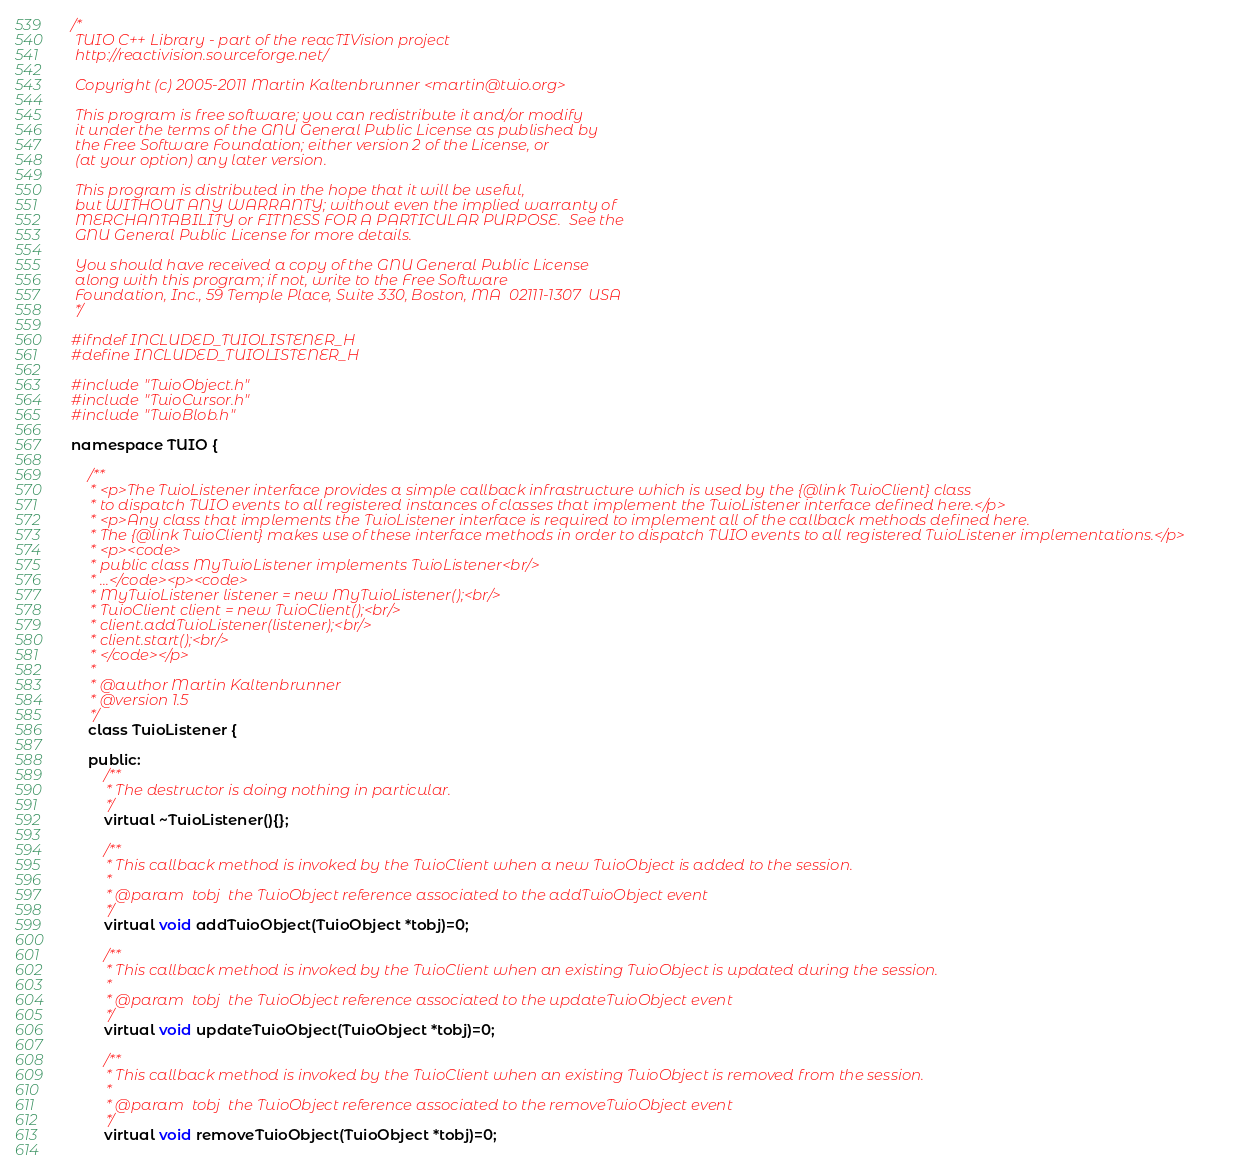Convert code to text. <code><loc_0><loc_0><loc_500><loc_500><_C_>/*
 TUIO C++ Library - part of the reacTIVision project
 http://reactivision.sourceforge.net/
 
 Copyright (c) 2005-2011 Martin Kaltenbrunner <martin@tuio.org>
 
 This program is free software; you can redistribute it and/or modify
 it under the terms of the GNU General Public License as published by
 the Free Software Foundation; either version 2 of the License, or
 (at your option) any later version.
 
 This program is distributed in the hope that it will be useful,
 but WITHOUT ANY WARRANTY; without even the implied warranty of
 MERCHANTABILITY or FITNESS FOR A PARTICULAR PURPOSE.  See the
 GNU General Public License for more details.
 
 You should have received a copy of the GNU General Public License
 along with this program; if not, write to the Free Software
 Foundation, Inc., 59 Temple Place, Suite 330, Boston, MA  02111-1307  USA
 */

#ifndef INCLUDED_TUIOLISTENER_H
#define INCLUDED_TUIOLISTENER_H

#include "TuioObject.h"
#include "TuioCursor.h"
#include "TuioBlob.h"

namespace TUIO {
	
	/**
	 * <p>The TuioListener interface provides a simple callback infrastructure which is used by the {@link TuioClient} class 
	 * to dispatch TUIO events to all registered instances of classes that implement the TuioListener interface defined here.</p> 
	 * <p>Any class that implements the TuioListener interface is required to implement all of the callback methods defined here.
	 * The {@link TuioClient} makes use of these interface methods in order to dispatch TUIO events to all registered TuioListener implementations.</p>
	 * <p><code>
	 * public class MyTuioListener implements TuioListener<br/>
	 * ...</code><p><code>
	 * MyTuioListener listener = new MyTuioListener();<br/>
	 * TuioClient client = new TuioClient();<br/>
	 * client.addTuioListener(listener);<br/>
	 * client.start();<br/>
	 * </code></p>
	 *
	 * @author Martin Kaltenbrunner
	 * @version 1.5
	 */
	class TuioListener { 
		
	public:
		/**
		 * The destructor is doing nothing in particular. 
		 */
		virtual ~TuioListener(){};
		
		/**
		 * This callback method is invoked by the TuioClient when a new TuioObject is added to the session.   
		 *
		 * @param  tobj  the TuioObject reference associated to the addTuioObject event
		 */
		virtual void addTuioObject(TuioObject *tobj)=0;

		/**
		 * This callback method is invoked by the TuioClient when an existing TuioObject is updated during the session.   
		 *
		 * @param  tobj  the TuioObject reference associated to the updateTuioObject event
		 */
		virtual void updateTuioObject(TuioObject *tobj)=0;
		
		/**
		 * This callback method is invoked by the TuioClient when an existing TuioObject is removed from the session.   
		 *
		 * @param  tobj  the TuioObject reference associated to the removeTuioObject event
		 */
		virtual void removeTuioObject(TuioObject *tobj)=0;
		</code> 